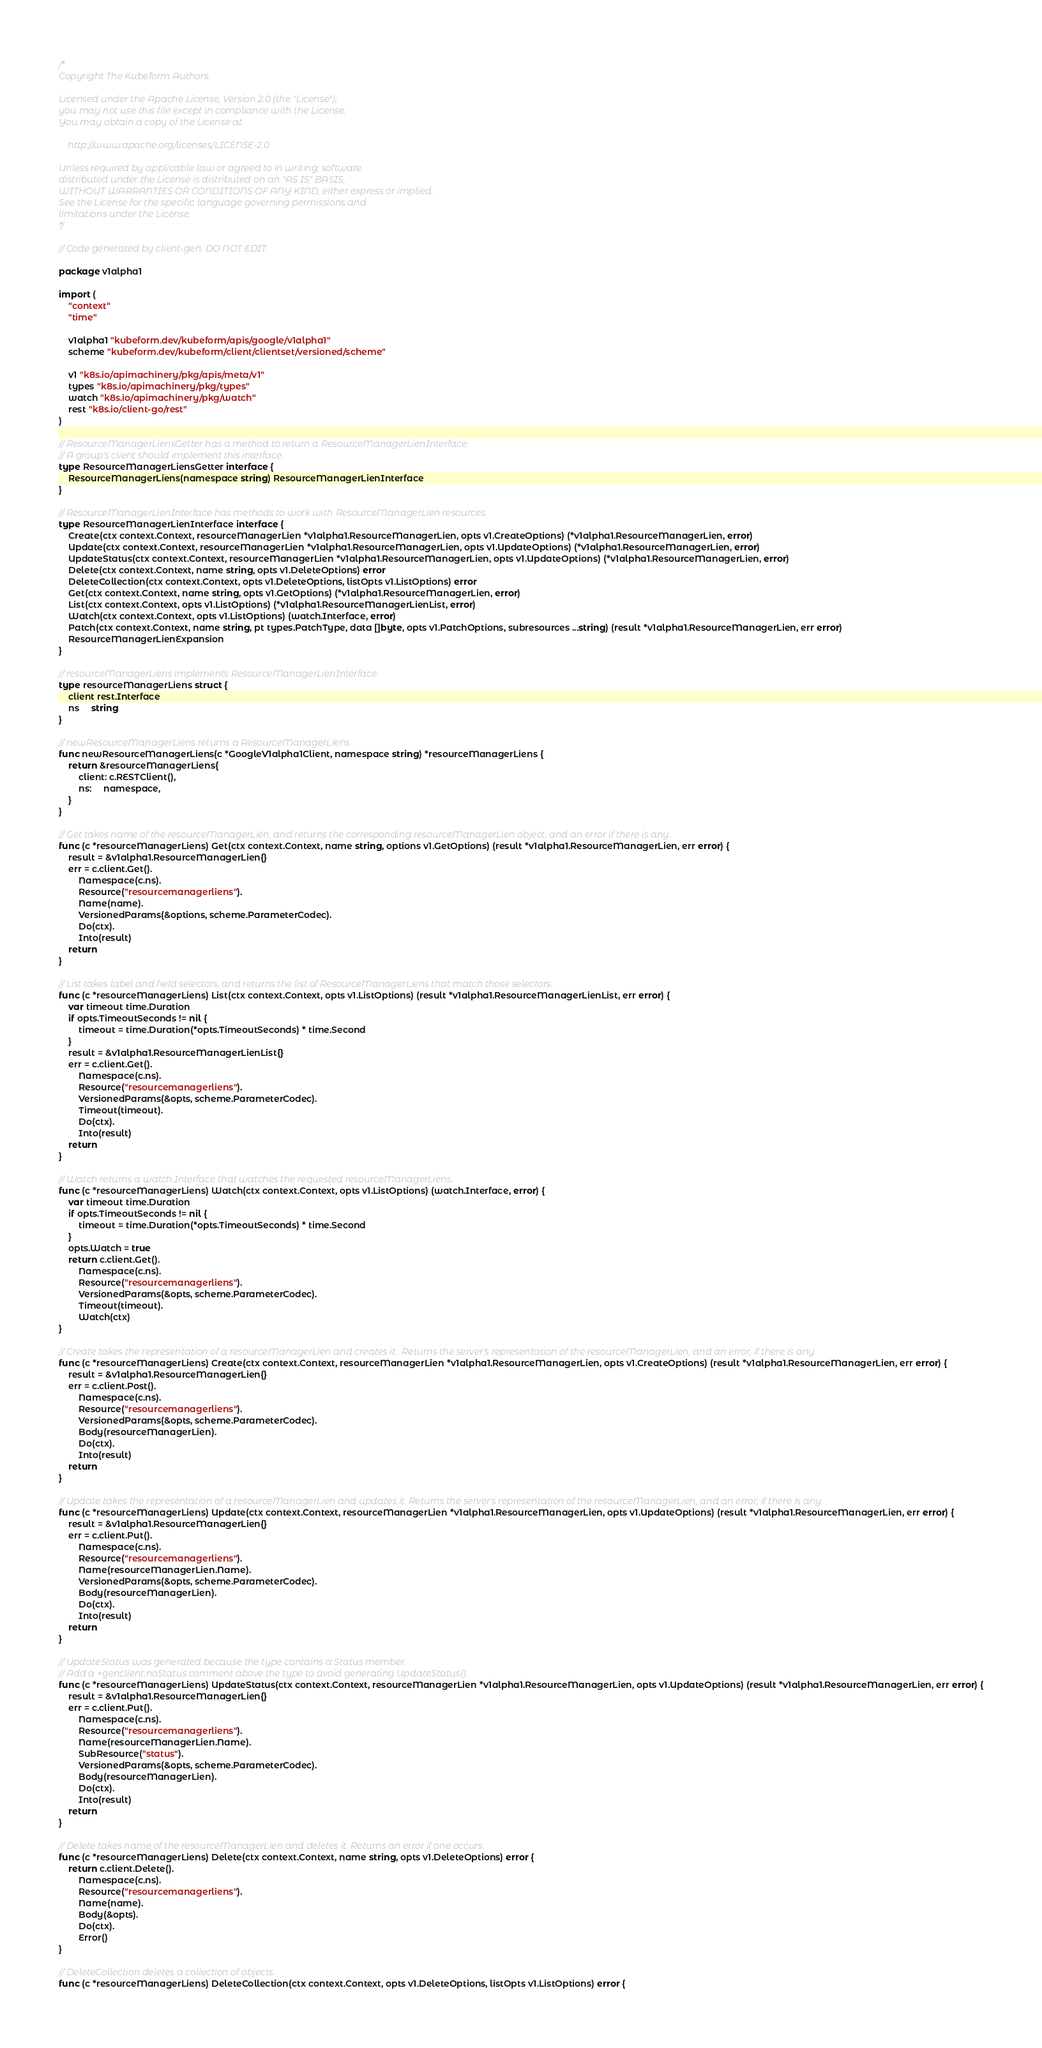Convert code to text. <code><loc_0><loc_0><loc_500><loc_500><_Go_>/*
Copyright The Kubeform Authors.

Licensed under the Apache License, Version 2.0 (the "License");
you may not use this file except in compliance with the License.
You may obtain a copy of the License at

    http://www.apache.org/licenses/LICENSE-2.0

Unless required by applicable law or agreed to in writing, software
distributed under the License is distributed on an "AS IS" BASIS,
WITHOUT WARRANTIES OR CONDITIONS OF ANY KIND, either express or implied.
See the License for the specific language governing permissions and
limitations under the License.
*/

// Code generated by client-gen. DO NOT EDIT.

package v1alpha1

import (
	"context"
	"time"

	v1alpha1 "kubeform.dev/kubeform/apis/google/v1alpha1"
	scheme "kubeform.dev/kubeform/client/clientset/versioned/scheme"

	v1 "k8s.io/apimachinery/pkg/apis/meta/v1"
	types "k8s.io/apimachinery/pkg/types"
	watch "k8s.io/apimachinery/pkg/watch"
	rest "k8s.io/client-go/rest"
)

// ResourceManagerLiensGetter has a method to return a ResourceManagerLienInterface.
// A group's client should implement this interface.
type ResourceManagerLiensGetter interface {
	ResourceManagerLiens(namespace string) ResourceManagerLienInterface
}

// ResourceManagerLienInterface has methods to work with ResourceManagerLien resources.
type ResourceManagerLienInterface interface {
	Create(ctx context.Context, resourceManagerLien *v1alpha1.ResourceManagerLien, opts v1.CreateOptions) (*v1alpha1.ResourceManagerLien, error)
	Update(ctx context.Context, resourceManagerLien *v1alpha1.ResourceManagerLien, opts v1.UpdateOptions) (*v1alpha1.ResourceManagerLien, error)
	UpdateStatus(ctx context.Context, resourceManagerLien *v1alpha1.ResourceManagerLien, opts v1.UpdateOptions) (*v1alpha1.ResourceManagerLien, error)
	Delete(ctx context.Context, name string, opts v1.DeleteOptions) error
	DeleteCollection(ctx context.Context, opts v1.DeleteOptions, listOpts v1.ListOptions) error
	Get(ctx context.Context, name string, opts v1.GetOptions) (*v1alpha1.ResourceManagerLien, error)
	List(ctx context.Context, opts v1.ListOptions) (*v1alpha1.ResourceManagerLienList, error)
	Watch(ctx context.Context, opts v1.ListOptions) (watch.Interface, error)
	Patch(ctx context.Context, name string, pt types.PatchType, data []byte, opts v1.PatchOptions, subresources ...string) (result *v1alpha1.ResourceManagerLien, err error)
	ResourceManagerLienExpansion
}

// resourceManagerLiens implements ResourceManagerLienInterface
type resourceManagerLiens struct {
	client rest.Interface
	ns     string
}

// newResourceManagerLiens returns a ResourceManagerLiens
func newResourceManagerLiens(c *GoogleV1alpha1Client, namespace string) *resourceManagerLiens {
	return &resourceManagerLiens{
		client: c.RESTClient(),
		ns:     namespace,
	}
}

// Get takes name of the resourceManagerLien, and returns the corresponding resourceManagerLien object, and an error if there is any.
func (c *resourceManagerLiens) Get(ctx context.Context, name string, options v1.GetOptions) (result *v1alpha1.ResourceManagerLien, err error) {
	result = &v1alpha1.ResourceManagerLien{}
	err = c.client.Get().
		Namespace(c.ns).
		Resource("resourcemanagerliens").
		Name(name).
		VersionedParams(&options, scheme.ParameterCodec).
		Do(ctx).
		Into(result)
	return
}

// List takes label and field selectors, and returns the list of ResourceManagerLiens that match those selectors.
func (c *resourceManagerLiens) List(ctx context.Context, opts v1.ListOptions) (result *v1alpha1.ResourceManagerLienList, err error) {
	var timeout time.Duration
	if opts.TimeoutSeconds != nil {
		timeout = time.Duration(*opts.TimeoutSeconds) * time.Second
	}
	result = &v1alpha1.ResourceManagerLienList{}
	err = c.client.Get().
		Namespace(c.ns).
		Resource("resourcemanagerliens").
		VersionedParams(&opts, scheme.ParameterCodec).
		Timeout(timeout).
		Do(ctx).
		Into(result)
	return
}

// Watch returns a watch.Interface that watches the requested resourceManagerLiens.
func (c *resourceManagerLiens) Watch(ctx context.Context, opts v1.ListOptions) (watch.Interface, error) {
	var timeout time.Duration
	if opts.TimeoutSeconds != nil {
		timeout = time.Duration(*opts.TimeoutSeconds) * time.Second
	}
	opts.Watch = true
	return c.client.Get().
		Namespace(c.ns).
		Resource("resourcemanagerliens").
		VersionedParams(&opts, scheme.ParameterCodec).
		Timeout(timeout).
		Watch(ctx)
}

// Create takes the representation of a resourceManagerLien and creates it.  Returns the server's representation of the resourceManagerLien, and an error, if there is any.
func (c *resourceManagerLiens) Create(ctx context.Context, resourceManagerLien *v1alpha1.ResourceManagerLien, opts v1.CreateOptions) (result *v1alpha1.ResourceManagerLien, err error) {
	result = &v1alpha1.ResourceManagerLien{}
	err = c.client.Post().
		Namespace(c.ns).
		Resource("resourcemanagerliens").
		VersionedParams(&opts, scheme.ParameterCodec).
		Body(resourceManagerLien).
		Do(ctx).
		Into(result)
	return
}

// Update takes the representation of a resourceManagerLien and updates it. Returns the server's representation of the resourceManagerLien, and an error, if there is any.
func (c *resourceManagerLiens) Update(ctx context.Context, resourceManagerLien *v1alpha1.ResourceManagerLien, opts v1.UpdateOptions) (result *v1alpha1.ResourceManagerLien, err error) {
	result = &v1alpha1.ResourceManagerLien{}
	err = c.client.Put().
		Namespace(c.ns).
		Resource("resourcemanagerliens").
		Name(resourceManagerLien.Name).
		VersionedParams(&opts, scheme.ParameterCodec).
		Body(resourceManagerLien).
		Do(ctx).
		Into(result)
	return
}

// UpdateStatus was generated because the type contains a Status member.
// Add a +genclient:noStatus comment above the type to avoid generating UpdateStatus().
func (c *resourceManagerLiens) UpdateStatus(ctx context.Context, resourceManagerLien *v1alpha1.ResourceManagerLien, opts v1.UpdateOptions) (result *v1alpha1.ResourceManagerLien, err error) {
	result = &v1alpha1.ResourceManagerLien{}
	err = c.client.Put().
		Namespace(c.ns).
		Resource("resourcemanagerliens").
		Name(resourceManagerLien.Name).
		SubResource("status").
		VersionedParams(&opts, scheme.ParameterCodec).
		Body(resourceManagerLien).
		Do(ctx).
		Into(result)
	return
}

// Delete takes name of the resourceManagerLien and deletes it. Returns an error if one occurs.
func (c *resourceManagerLiens) Delete(ctx context.Context, name string, opts v1.DeleteOptions) error {
	return c.client.Delete().
		Namespace(c.ns).
		Resource("resourcemanagerliens").
		Name(name).
		Body(&opts).
		Do(ctx).
		Error()
}

// DeleteCollection deletes a collection of objects.
func (c *resourceManagerLiens) DeleteCollection(ctx context.Context, opts v1.DeleteOptions, listOpts v1.ListOptions) error {</code> 